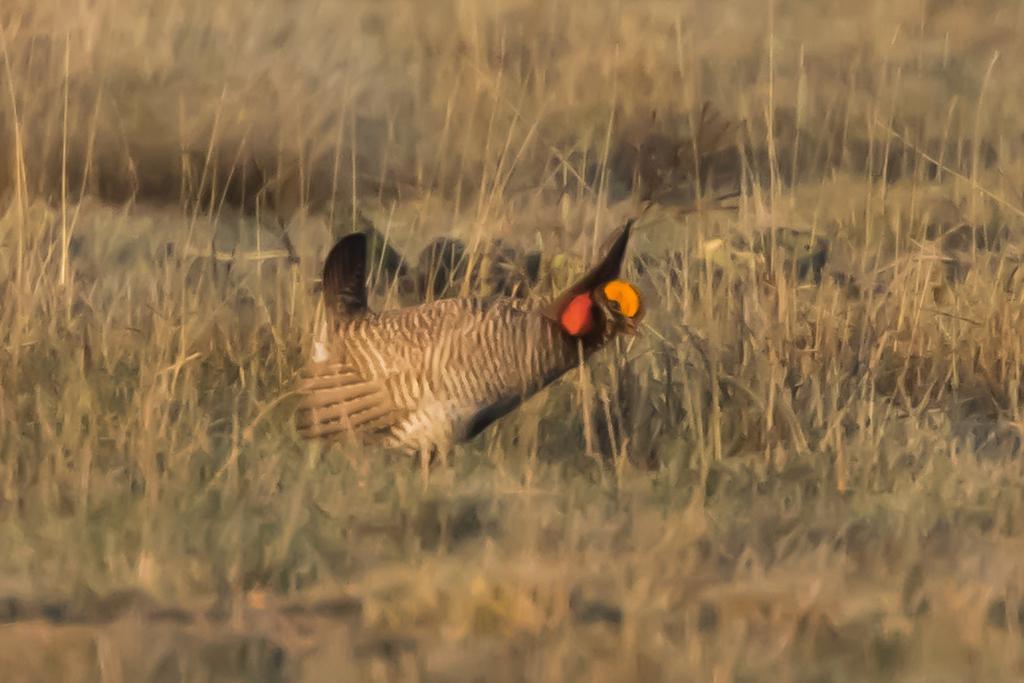Please provide a concise description of this image. In this image there is a cock on the surface of the grass. 